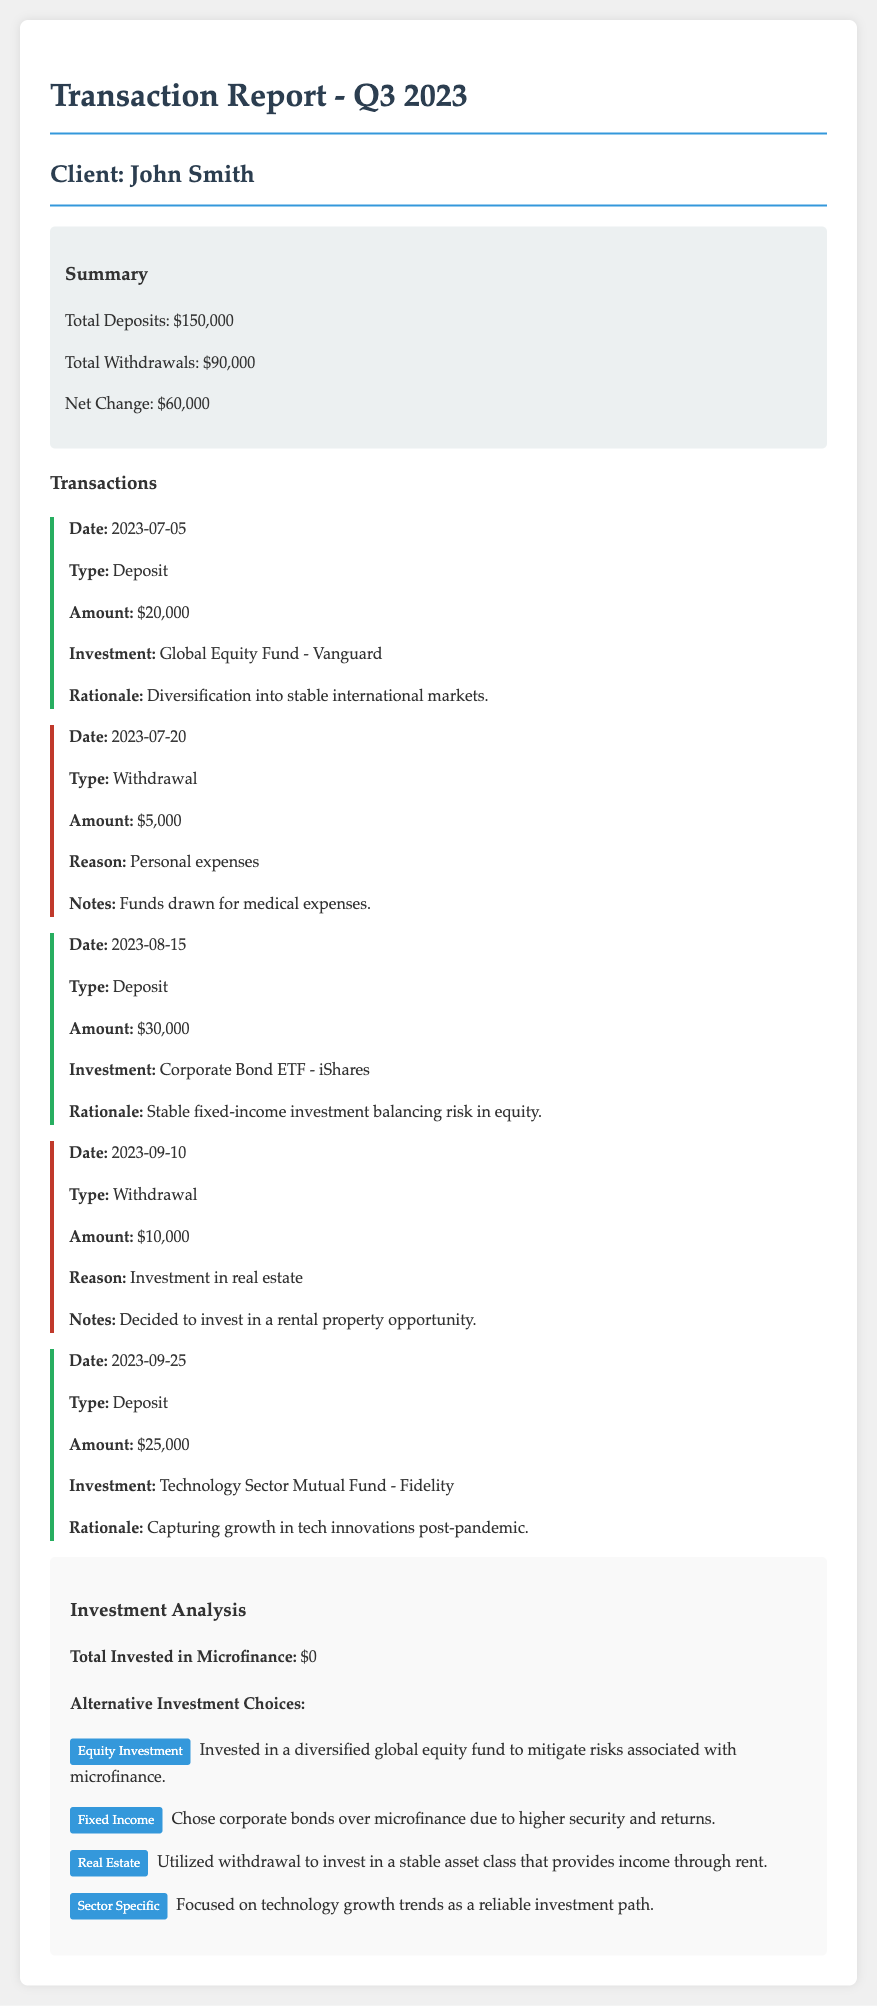What is the total of deposits? The total of deposits is calculated by adding all deposit amounts listed in the document, which are $20,000, $30,000, and $25,000.
Answer: $150,000 What is the total of withdrawals? The total of withdrawals is the sum of all withdrawal amounts listed, which are $5,000 and $10,000.
Answer: $90,000 What was the date of the first deposit? The date of the first deposit is provided in the transaction list, which shows July 5, 2023, as the date for the first deposit.
Answer: 2023-07-05 Which investment returned the most based on Charles's diversification strategy? The document mentions that the investments focus on various areas, but the specific returns are not provided; however, it emphasizes the global equity fund for diversification.
Answer: Global Equity Fund - Vanguard How much was withdrawn for investment in real estate? The document outlines a specific withdrawal for investment, which amounts to $10,000.
Answer: $10,000 What were the two primary investment strategies highlighted besides microfinance? The document details a structured approach to investing with one strategy focused on fixed income and another on sector-specific selection.
Answer: Fixed Income and Sector Specific What rationale is given for the investment in the Technology Sector Mutual Fund? The document states that the rationale for this investment was to capture growth in tech innovations post-pandemic.
Answer: Capturing growth in tech innovations post-pandemic What kind of investment was made on August 15, 2023? The investment made on August 15, 2023, was identified as a Corporate Bond ETF specifically mentioning the provider as iShares.
Answer: Corporate Bond ETF - iShares How much money was invested in microfinance? The document explicitly states that the total invested in microfinance was $0.
Answer: $0 